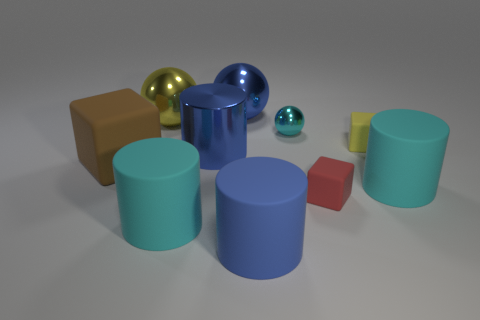There is a blue cylinder that is behind the red rubber object; is its size the same as the red cube?
Keep it short and to the point. No. There is a tiny matte object behind the tiny rubber thing in front of the large brown matte object; what number of large rubber cylinders are on the right side of it?
Offer a very short reply. 1. What size is the cyan thing that is both to the left of the yellow matte cube and on the right side of the blue ball?
Make the answer very short. Small. How many other things are there of the same shape as the big yellow object?
Provide a succinct answer. 2. How many large blue things are in front of the large yellow metallic sphere?
Ensure brevity in your answer.  2. Is the number of blue cylinders that are behind the small yellow rubber cube less than the number of large cyan objects that are to the left of the big blue rubber cylinder?
Give a very brief answer. Yes. What shape is the big cyan rubber thing that is to the left of the cyan matte cylinder that is behind the tiny thing that is in front of the tiny yellow rubber cube?
Make the answer very short. Cylinder. What is the shape of the big blue thing that is both in front of the large blue metal ball and behind the brown matte object?
Offer a very short reply. Cylinder. Is there a yellow block that has the same material as the big brown cube?
Keep it short and to the point. Yes. There is a matte cylinder that is the same color as the large metal cylinder; what is its size?
Your answer should be compact. Large. 